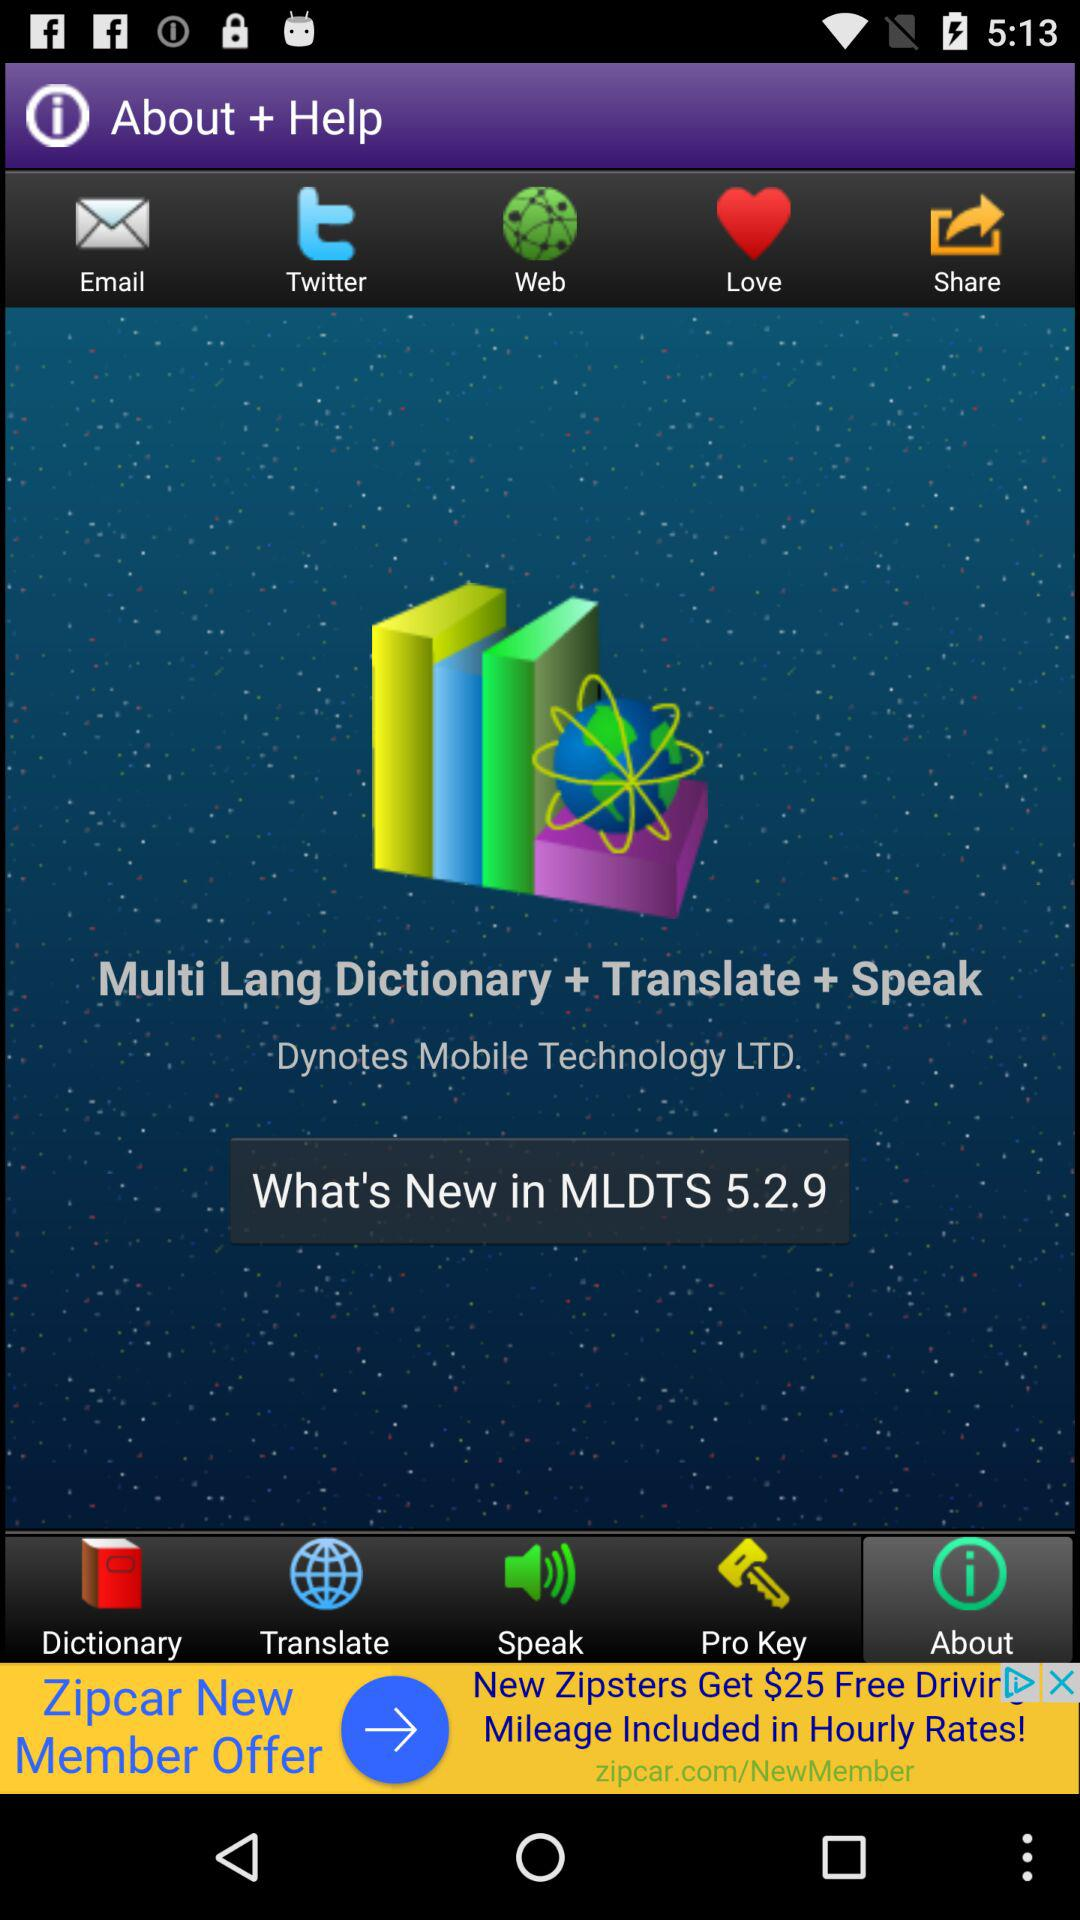What is the version? The version is 5.2.9. 